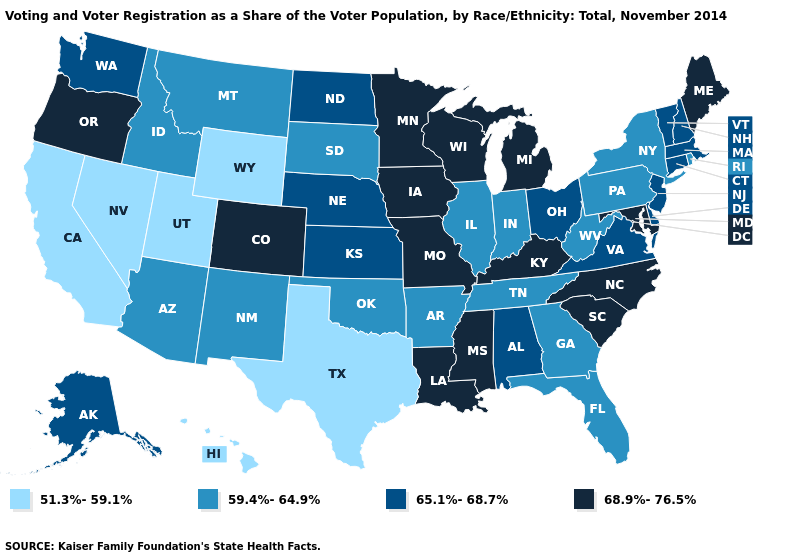What is the value of Iowa?
Quick response, please. 68.9%-76.5%. What is the value of Missouri?
Keep it brief. 68.9%-76.5%. Does Mississippi have a higher value than Wisconsin?
Short answer required. No. What is the highest value in the MidWest ?
Concise answer only. 68.9%-76.5%. What is the highest value in the USA?
Answer briefly. 68.9%-76.5%. What is the highest value in the Northeast ?
Answer briefly. 68.9%-76.5%. Among the states that border Oklahoma , does New Mexico have the lowest value?
Concise answer only. No. Name the states that have a value in the range 68.9%-76.5%?
Short answer required. Colorado, Iowa, Kentucky, Louisiana, Maine, Maryland, Michigan, Minnesota, Mississippi, Missouri, North Carolina, Oregon, South Carolina, Wisconsin. Among the states that border Pennsylvania , which have the highest value?
Answer briefly. Maryland. What is the value of Illinois?
Quick response, please. 59.4%-64.9%. What is the value of Texas?
Write a very short answer. 51.3%-59.1%. What is the lowest value in states that border Virginia?
Give a very brief answer. 59.4%-64.9%. What is the lowest value in the MidWest?
Keep it brief. 59.4%-64.9%. Name the states that have a value in the range 59.4%-64.9%?
Give a very brief answer. Arizona, Arkansas, Florida, Georgia, Idaho, Illinois, Indiana, Montana, New Mexico, New York, Oklahoma, Pennsylvania, Rhode Island, South Dakota, Tennessee, West Virginia. Does Illinois have the lowest value in the MidWest?
Concise answer only. Yes. 